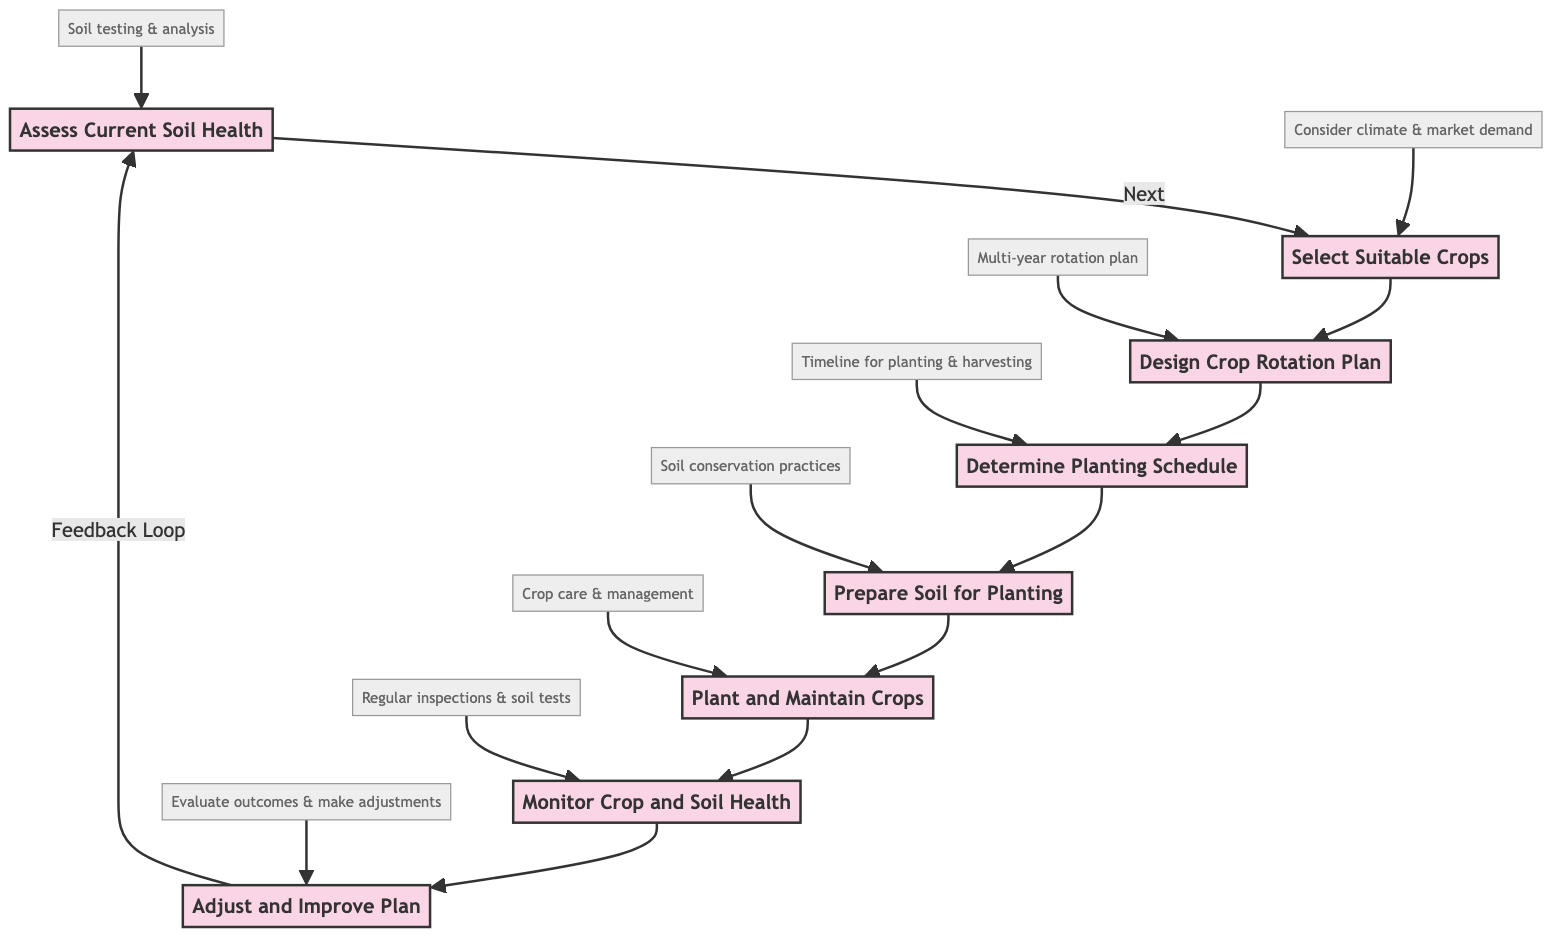What is the first step in the process? The first step in the flow chart is "Assess Current Soil Health." This is indicated as the starting node of the diagram, leading to the next step in the sequence.
Answer: Assess Current Soil Health How many steps are there in total? By counting all the unique steps in the flow chart, from "Assess Current Soil Health" to "Adjust and Improve Plan," there are a total of eight steps.
Answer: Eight What step follows the "Design Crop Rotation Plan"? The step that follows "Design Crop Rotation Plan" is "Determine Planting Schedule." The arrows in the flow chart indicate the sequence of steps, leading from one to the next.
Answer: Determine Planting Schedule What are the main activities included in the "Prepare Soil for Planting"? The detailed description for "Prepare Soil for Planting" includes implementing soil conservation practices such as cover cropping, mulching, and minimal tillage. These activities are necessary to prepare the soil effectively for planting.
Answer: Soil conservation practices What happens after "Monitor Crop and Soil Health"? After "Monitor Crop and Soil Health," the process leads to "Adjust and Improve Plan." The flow chart shows that monitoring results leads to evaluations and subsequent adjustments in the plan.
Answer: Adjust and Improve Plan How does the flow of the steps indicate feedback? The flow chart indicates a feedback loop from "Adjust and Improve Plan" back to "Assess Current Soil Health." This signifies that outcomes are evaluated and then the process can start again to ensure continuous improvement in soil management.
Answer: Feedback loop Which step emphasizes the importance of market demand in selection? The step "Select Suitable Crops" emphasizes the importance of market demand in selection, as indicated in the detailed description where it mentions considering local climate, soil conditions, and market demand when choosing crops.
Answer: Select Suitable Crops What is the purpose of conducting "Regular inspections & soil tests"? The purpose of conducting "Regular inspections & soil tests" under the "Monitor Crop and Soil Health" step is to track changes in soil fertility and assess crop health, ensuring any issues can be addressed promptly.
Answer: Track changes in soil fertility What does the "Adjust and Improve Plan" step require for evaluation? The "Adjust and Improve Plan" step requires evaluations based on soil health data, crop performance, and feedback from stakeholders to make informed adjustments to the crop rotation plan.
Answer: Evaluations based on data and feedback 